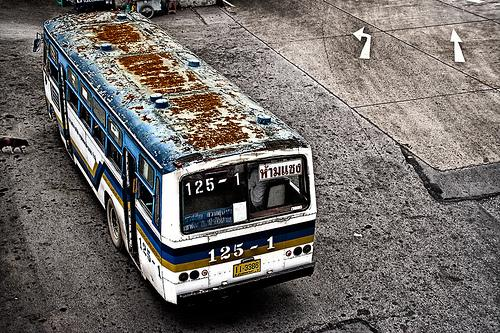What work does this bus need to have done on it?

Choices:
A) wheels rotated
B) paint roof
C) reverse signaling
D) retraining paint roof 